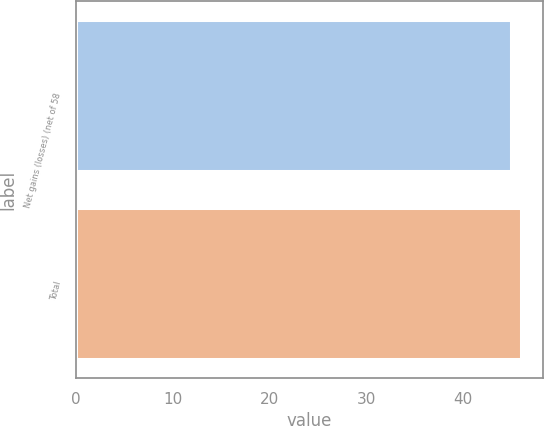Convert chart to OTSL. <chart><loc_0><loc_0><loc_500><loc_500><bar_chart><fcel>Net gains (losses) (net of 58<fcel>Total<nl><fcel>45<fcel>46<nl></chart> 